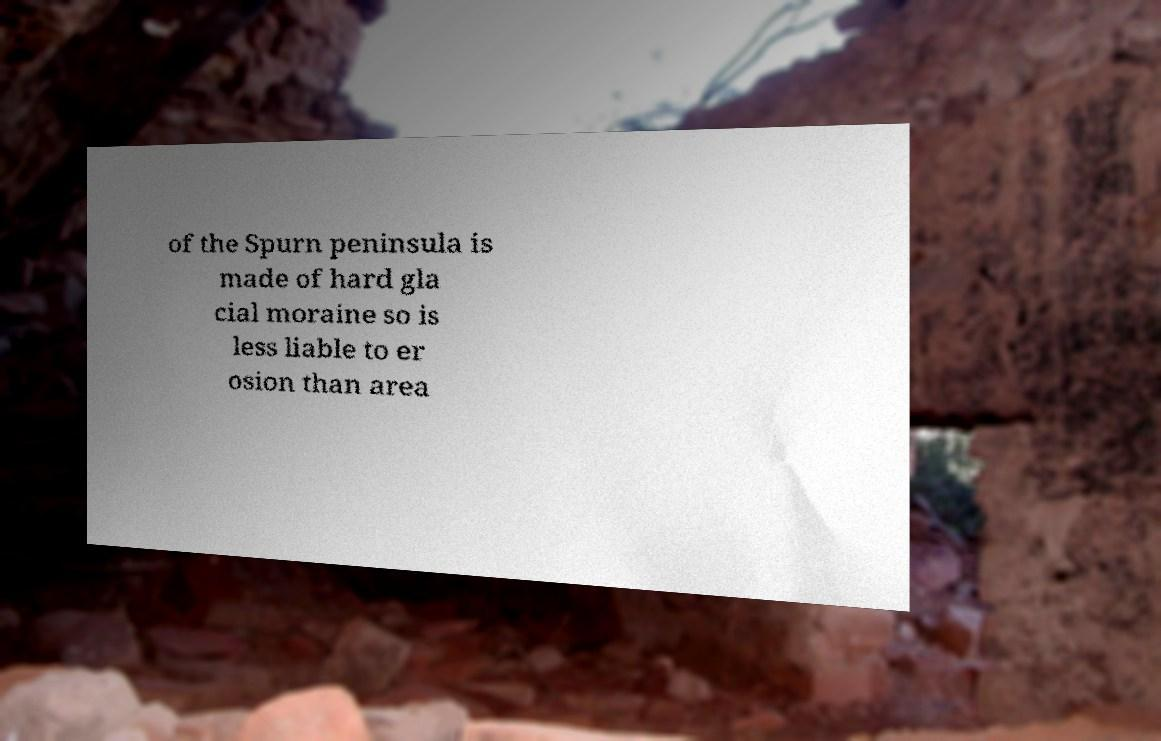I need the written content from this picture converted into text. Can you do that? of the Spurn peninsula is made of hard gla cial moraine so is less liable to er osion than area 